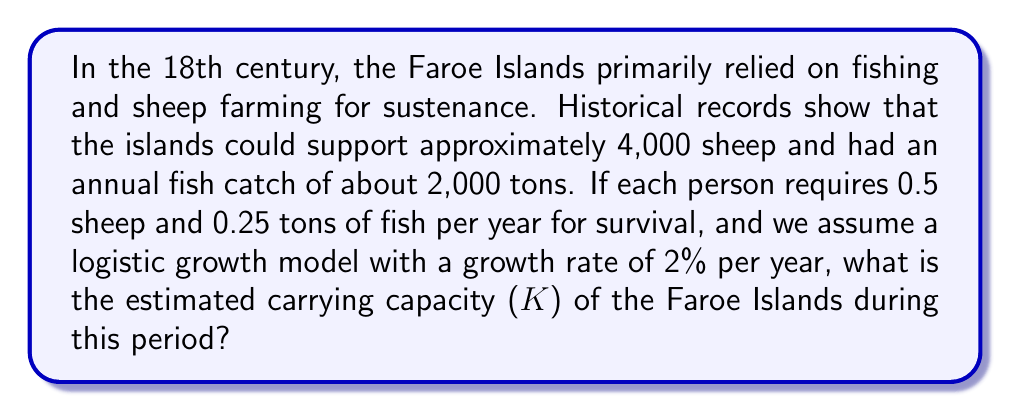Can you answer this question? To solve this problem, we'll use the logistic growth model and the given information about resource availability. Let's break it down step by step:

1. Resource availability:
   - Sheep: 4,000
   - Fish: 2,000 tons per year

2. Individual requirements:
   - 0.5 sheep per person per year
   - 0.25 tons of fish per person per year

3. Calculate the number of people that can be supported by each resource:
   - Sheep capacity: $4,000 \div 0.5 = 8,000$ people
   - Fish capacity: $2,000 \div 0.25 = 8,000$ people

4. The limiting factor is the resource with the lower capacity, but in this case, both resources can support 8,000 people.

5. The logistic growth model is given by the equation:

   $$\frac{dN}{dt} = rN(1 - \frac{N}{K})$$

   Where:
   - $N$ is the population size
   - $r$ is the growth rate (2% or 0.02 in this case)
   - $K$ is the carrying capacity

6. At carrying capacity, the population growth rate is zero:

   $$0 = rK(1 - \frac{K}{K})$$

7. This simplifies to:

   $$0 = rK(0)$$

   Which is true for any value of $K$.

8. Therefore, the carrying capacity $K$ is determined by the resource limitations, which we calculated to be 8,000 people.
Answer: The estimated carrying capacity (K) of the Faroe Islands during this period is 8,000 people. 